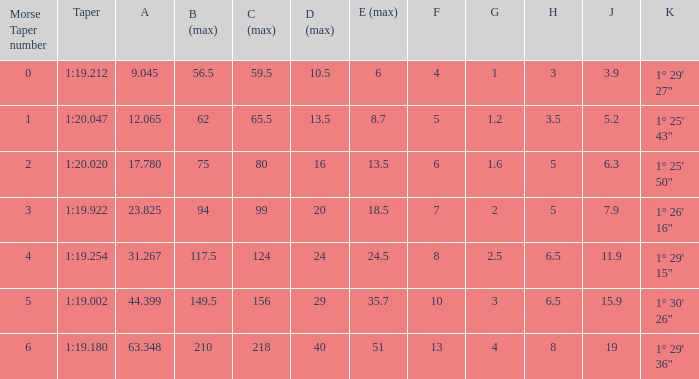Name the least morse taper number when taper is 1:20.047 1.0. 